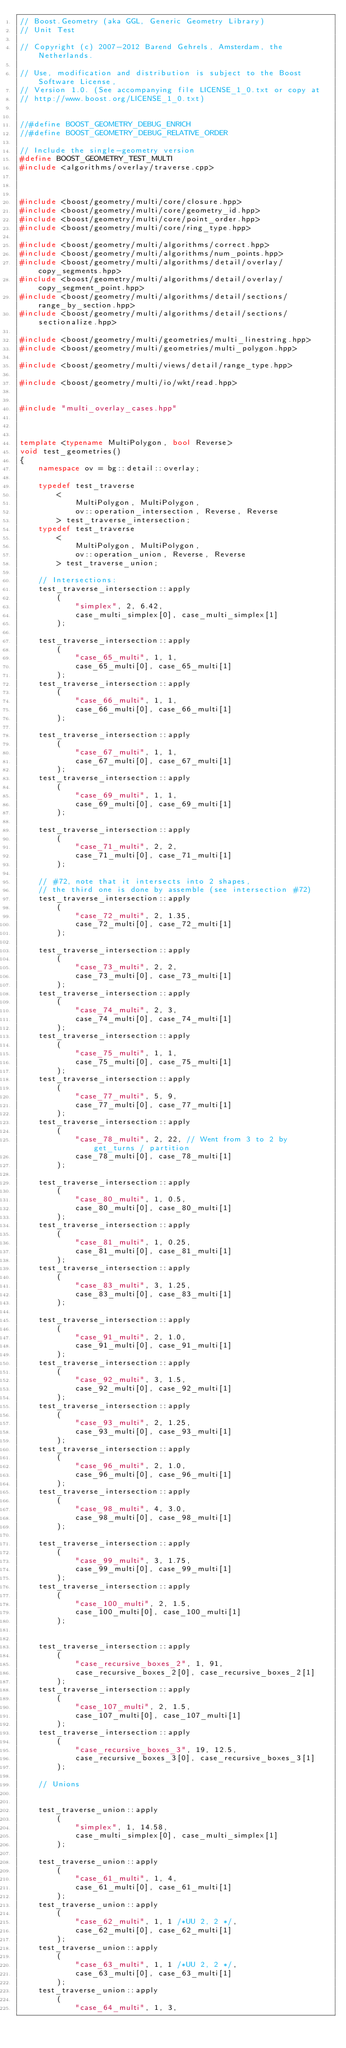Convert code to text. <code><loc_0><loc_0><loc_500><loc_500><_C++_>// Boost.Geometry (aka GGL, Generic Geometry Library)
// Unit Test

// Copyright (c) 2007-2012 Barend Gehrels, Amsterdam, the Netherlands.

// Use, modification and distribution is subject to the Boost Software License,
// Version 1.0. (See accompanying file LICENSE_1_0.txt or copy at
// http://www.boost.org/LICENSE_1_0.txt)


//#define BOOST_GEOMETRY_DEBUG_ENRICH
//#define BOOST_GEOMETRY_DEBUG_RELATIVE_ORDER

// Include the single-geometry version
#define BOOST_GEOMETRY_TEST_MULTI
#include <algorithms/overlay/traverse.cpp>



#include <boost/geometry/multi/core/closure.hpp>
#include <boost/geometry/multi/core/geometry_id.hpp>
#include <boost/geometry/multi/core/point_order.hpp>
#include <boost/geometry/multi/core/ring_type.hpp>

#include <boost/geometry/multi/algorithms/correct.hpp>
#include <boost/geometry/multi/algorithms/num_points.hpp>
#include <boost/geometry/multi/algorithms/detail/overlay/copy_segments.hpp>
#include <boost/geometry/multi/algorithms/detail/overlay/copy_segment_point.hpp>
#include <boost/geometry/multi/algorithms/detail/sections/range_by_section.hpp>
#include <boost/geometry/multi/algorithms/detail/sections/sectionalize.hpp>

#include <boost/geometry/multi/geometries/multi_linestring.hpp>
#include <boost/geometry/multi/geometries/multi_polygon.hpp>

#include <boost/geometry/multi/views/detail/range_type.hpp>

#include <boost/geometry/multi/io/wkt/read.hpp>


#include "multi_overlay_cases.hpp"



template <typename MultiPolygon, bool Reverse>
void test_geometries()
{
    namespace ov = bg::detail::overlay;

    typedef test_traverse
        <
            MultiPolygon, MultiPolygon,
            ov::operation_intersection, Reverse, Reverse
        > test_traverse_intersection;
    typedef test_traverse
        <
            MultiPolygon, MultiPolygon,
            ov::operation_union, Reverse, Reverse
        > test_traverse_union;

    // Intersections:
    test_traverse_intersection::apply
        (
            "simplex", 2, 6.42,
            case_multi_simplex[0], case_multi_simplex[1]
        );

    test_traverse_intersection::apply
        (
            "case_65_multi", 1, 1,
            case_65_multi[0], case_65_multi[1]
        );
    test_traverse_intersection::apply
        (
            "case_66_multi", 1, 1,
            case_66_multi[0], case_66_multi[1]
        );

    test_traverse_intersection::apply
        (
            "case_67_multi", 1, 1,
            case_67_multi[0], case_67_multi[1]
        );
    test_traverse_intersection::apply
        (
            "case_69_multi", 1, 1,
            case_69_multi[0], case_69_multi[1]
        );

    test_traverse_intersection::apply
        (
            "case_71_multi", 2, 2,
            case_71_multi[0], case_71_multi[1]
        );

    // #72, note that it intersects into 2 shapes,
    // the third one is done by assemble (see intersection #72)
    test_traverse_intersection::apply
        (
            "case_72_multi", 2, 1.35,
            case_72_multi[0], case_72_multi[1]
        );

    test_traverse_intersection::apply
        (
            "case_73_multi", 2, 2,
            case_73_multi[0], case_73_multi[1]
        );
    test_traverse_intersection::apply
        (
            "case_74_multi", 2, 3,
            case_74_multi[0], case_74_multi[1]
        );
    test_traverse_intersection::apply
        (
            "case_75_multi", 1, 1,
            case_75_multi[0], case_75_multi[1]
        );
    test_traverse_intersection::apply
        (
            "case_77_multi", 5, 9,
            case_77_multi[0], case_77_multi[1]
        );
    test_traverse_intersection::apply
        (
            "case_78_multi", 2, 22, // Went from 3 to 2 by get_turns / partition
            case_78_multi[0], case_78_multi[1]
        );

    test_traverse_intersection::apply
        (
            "case_80_multi", 1, 0.5,
            case_80_multi[0], case_80_multi[1]
        );
    test_traverse_intersection::apply
        (
            "case_81_multi", 1, 0.25,
            case_81_multi[0], case_81_multi[1]
        );
    test_traverse_intersection::apply
        (
            "case_83_multi", 3, 1.25,
            case_83_multi[0], case_83_multi[1]
        );

    test_traverse_intersection::apply
        (
            "case_91_multi", 2, 1.0,
            case_91_multi[0], case_91_multi[1]
        );
    test_traverse_intersection::apply
        (
            "case_92_multi", 3, 1.5,
            case_92_multi[0], case_92_multi[1]
        );
    test_traverse_intersection::apply
        (
            "case_93_multi", 2, 1.25,
            case_93_multi[0], case_93_multi[1]
        );
    test_traverse_intersection::apply
        (
            "case_96_multi", 2, 1.0,
            case_96_multi[0], case_96_multi[1]
        );
    test_traverse_intersection::apply
        (
            "case_98_multi", 4, 3.0,
            case_98_multi[0], case_98_multi[1]
        );

    test_traverse_intersection::apply
        (
            "case_99_multi", 3, 1.75,
            case_99_multi[0], case_99_multi[1]
        );
    test_traverse_intersection::apply
        (
            "case_100_multi", 2, 1.5,
            case_100_multi[0], case_100_multi[1]
        );


    test_traverse_intersection::apply
        (
            "case_recursive_boxes_2", 1, 91,
            case_recursive_boxes_2[0], case_recursive_boxes_2[1]
        );
    test_traverse_intersection::apply
        (
            "case_107_multi", 2, 1.5,
            case_107_multi[0], case_107_multi[1]
        );
    test_traverse_intersection::apply
        (
            "case_recursive_boxes_3", 19, 12.5,
            case_recursive_boxes_3[0], case_recursive_boxes_3[1]
        );

    // Unions


    test_traverse_union::apply
        (
            "simplex", 1, 14.58,
            case_multi_simplex[0], case_multi_simplex[1]
        );

    test_traverse_union::apply
        (
            "case_61_multi", 1, 4,
            case_61_multi[0], case_61_multi[1]
        );
    test_traverse_union::apply
        (
            "case_62_multi", 1, 1 /*UU 2, 2 */,
            case_62_multi[0], case_62_multi[1]
        );
    test_traverse_union::apply
        (
            "case_63_multi", 1, 1 /*UU 2, 2 */,
            case_63_multi[0], case_63_multi[1]
        );
    test_traverse_union::apply
        (
            "case_64_multi", 1, 3,</code> 